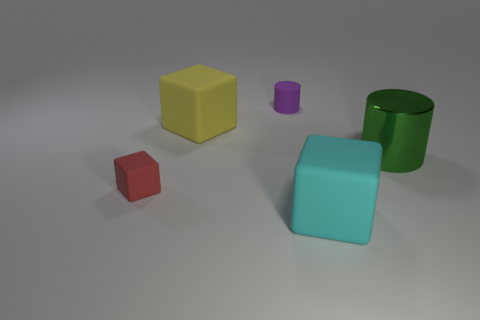How many things are either small red cubes or blue metallic cubes?
Your response must be concise. 1. The thing that is on the left side of the green metal object and right of the purple cylinder has what shape?
Make the answer very short. Cube. What number of green metallic cylinders are there?
Your answer should be compact. 1. What color is the small block that is made of the same material as the tiny cylinder?
Give a very brief answer. Red. Are there more red shiny cylinders than cyan rubber things?
Your answer should be very brief. No. There is a rubber object that is both to the right of the red rubber object and to the left of the purple thing; what is its size?
Provide a short and direct response. Large. Are there the same number of matte cubes that are behind the red matte object and large cyan objects?
Ensure brevity in your answer.  Yes. Do the purple cylinder and the cyan matte thing have the same size?
Give a very brief answer. No. There is a matte cube that is both in front of the large green metal cylinder and on the left side of the large cyan matte object; what is its color?
Your answer should be very brief. Red. What is the material of the thing to the right of the rubber object that is in front of the small red block?
Your answer should be very brief. Metal. 